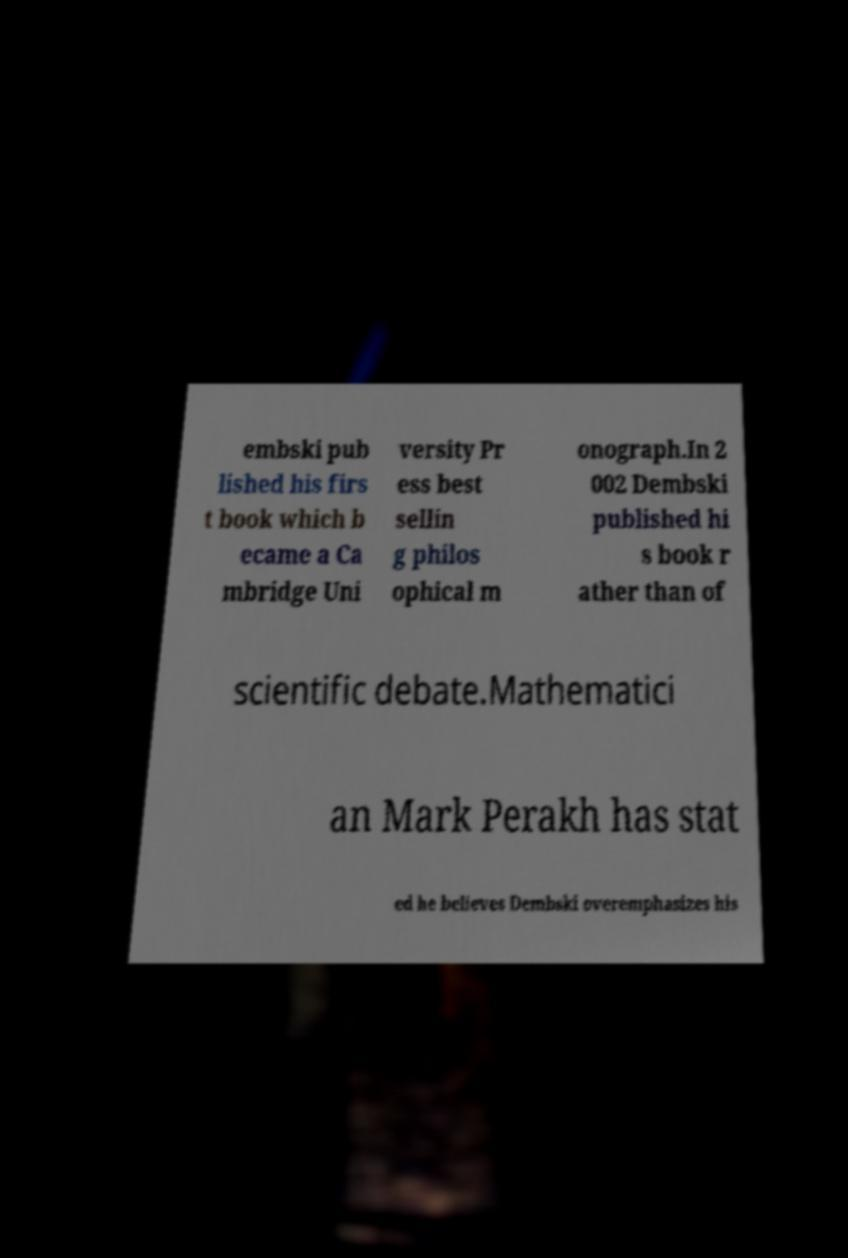Could you extract and type out the text from this image? embski pub lished his firs t book which b ecame a Ca mbridge Uni versity Pr ess best sellin g philos ophical m onograph.In 2 002 Dembski published hi s book r ather than of scientific debate.Mathematici an Mark Perakh has stat ed he believes Dembski overemphasizes his 